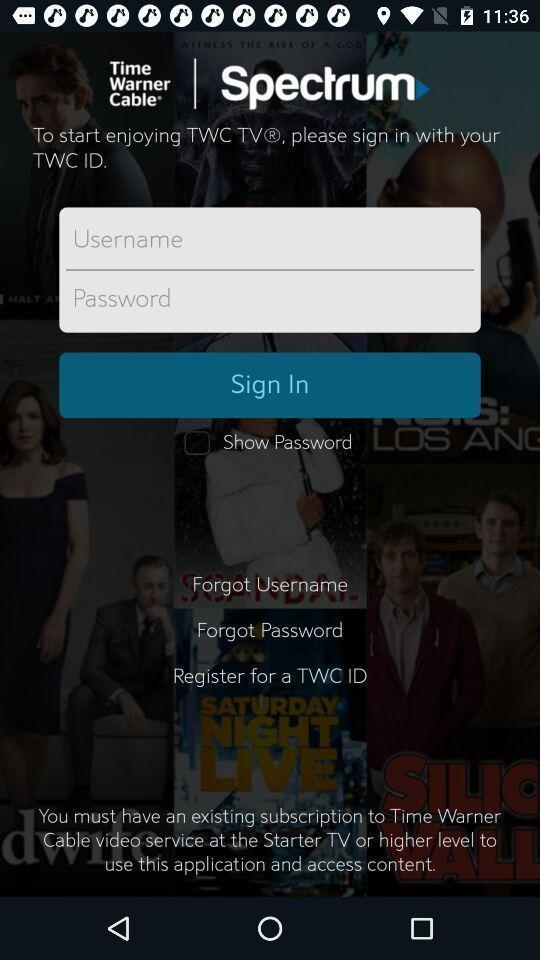Summarize the main components in this picture. Sign in page of app. 